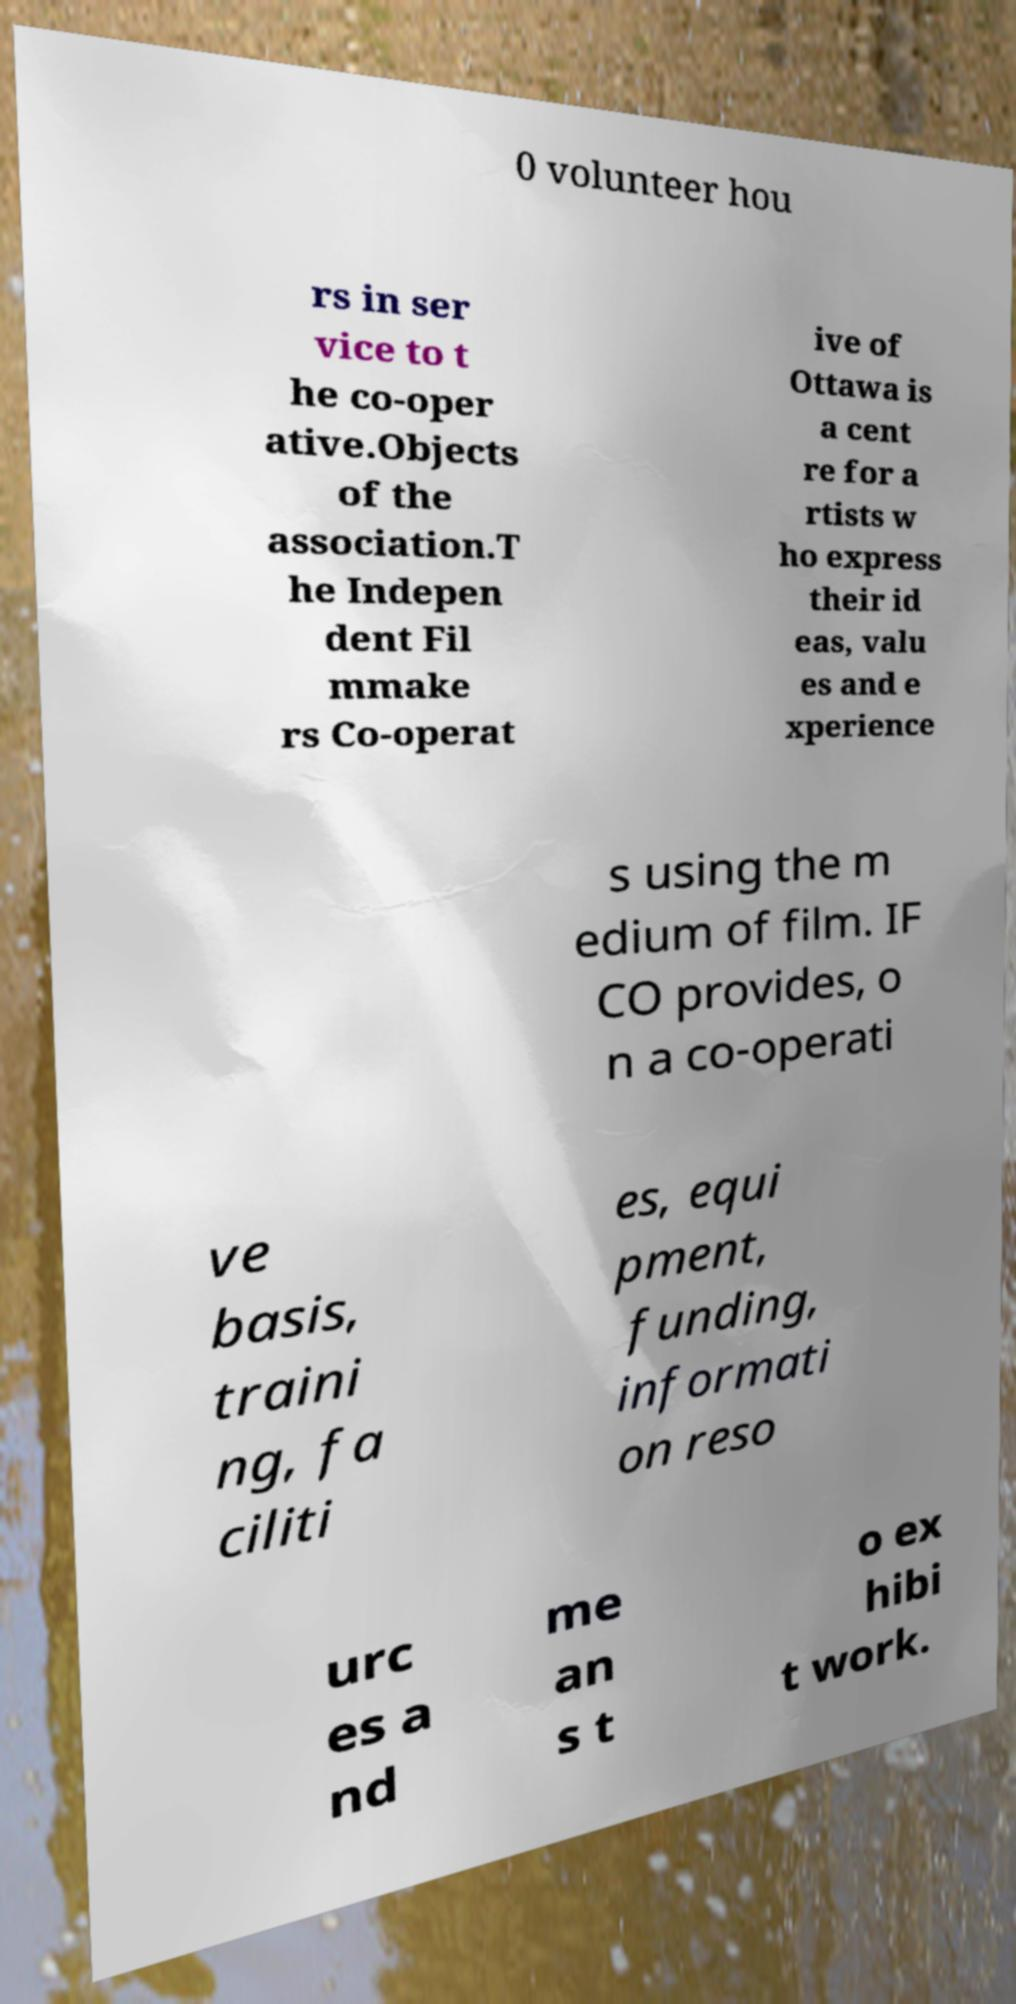There's text embedded in this image that I need extracted. Can you transcribe it verbatim? 0 volunteer hou rs in ser vice to t he co-oper ative.Objects of the association.T he Indepen dent Fil mmake rs Co-operat ive of Ottawa is a cent re for a rtists w ho express their id eas, valu es and e xperience s using the m edium of film. IF CO provides, o n a co-operati ve basis, traini ng, fa ciliti es, equi pment, funding, informati on reso urc es a nd me an s t o ex hibi t work. 